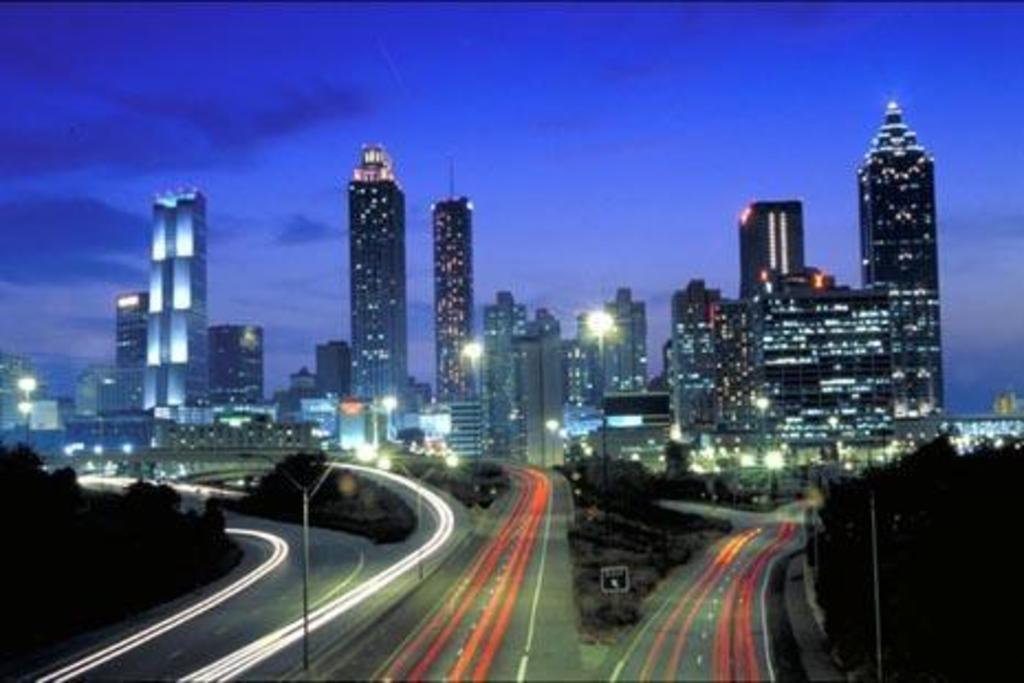What can be seen in the foreground of the image? In the foreground of the image, there are poles, trees, and vehicles on the road. What is visible in the background of the image? In the background of the image, there are buildings and towers. What is the condition of the sky in the image? The sky is visible at the top of the image, and it appears to be nighttime. How many types of structures are visible in the background? There are two types of structures visible in the background: buildings and towers. Where is the boy playing with snakes in the image? There is no boy or snakes present in the image. What is the position of the snakes in the image? There are no snakes present in the image, so their position cannot be determined. 